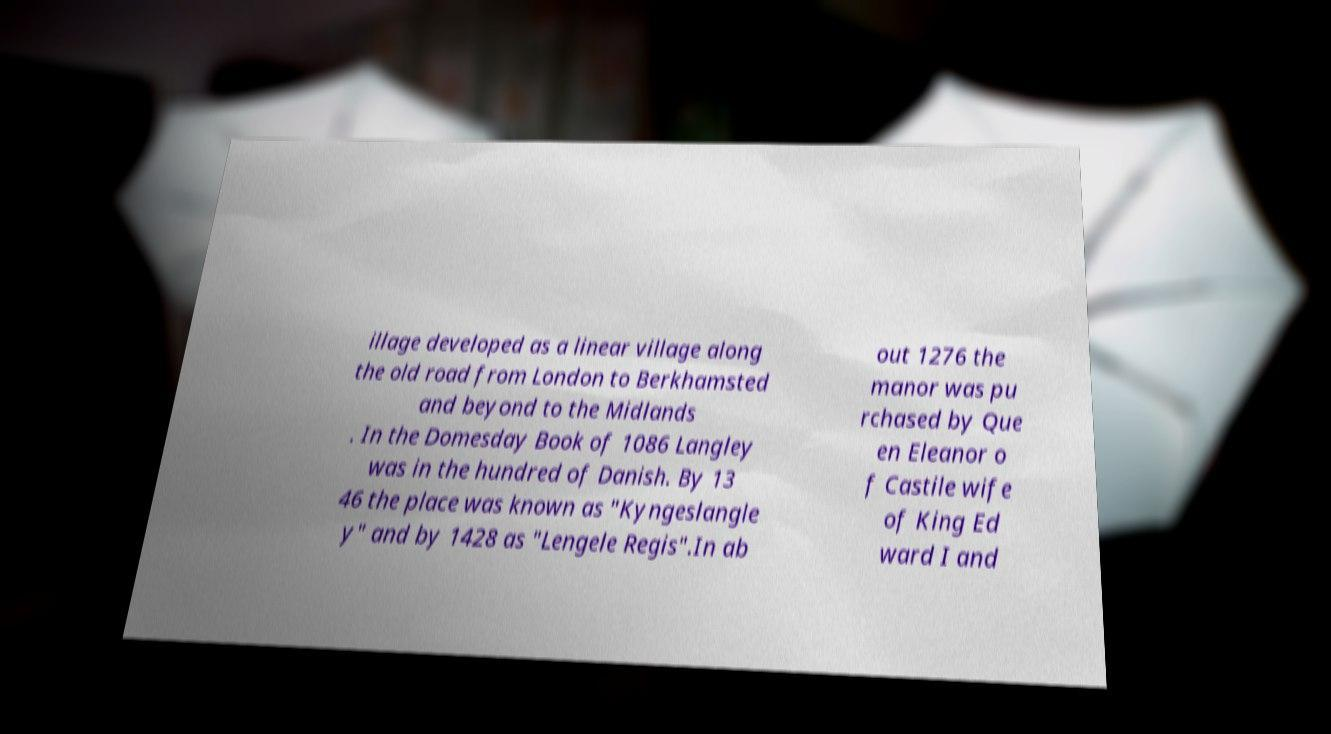Please read and relay the text visible in this image. What does it say? illage developed as a linear village along the old road from London to Berkhamsted and beyond to the Midlands . In the Domesday Book of 1086 Langley was in the hundred of Danish. By 13 46 the place was known as "Kyngeslangle y" and by 1428 as "Lengele Regis".In ab out 1276 the manor was pu rchased by Que en Eleanor o f Castile wife of King Ed ward I and 